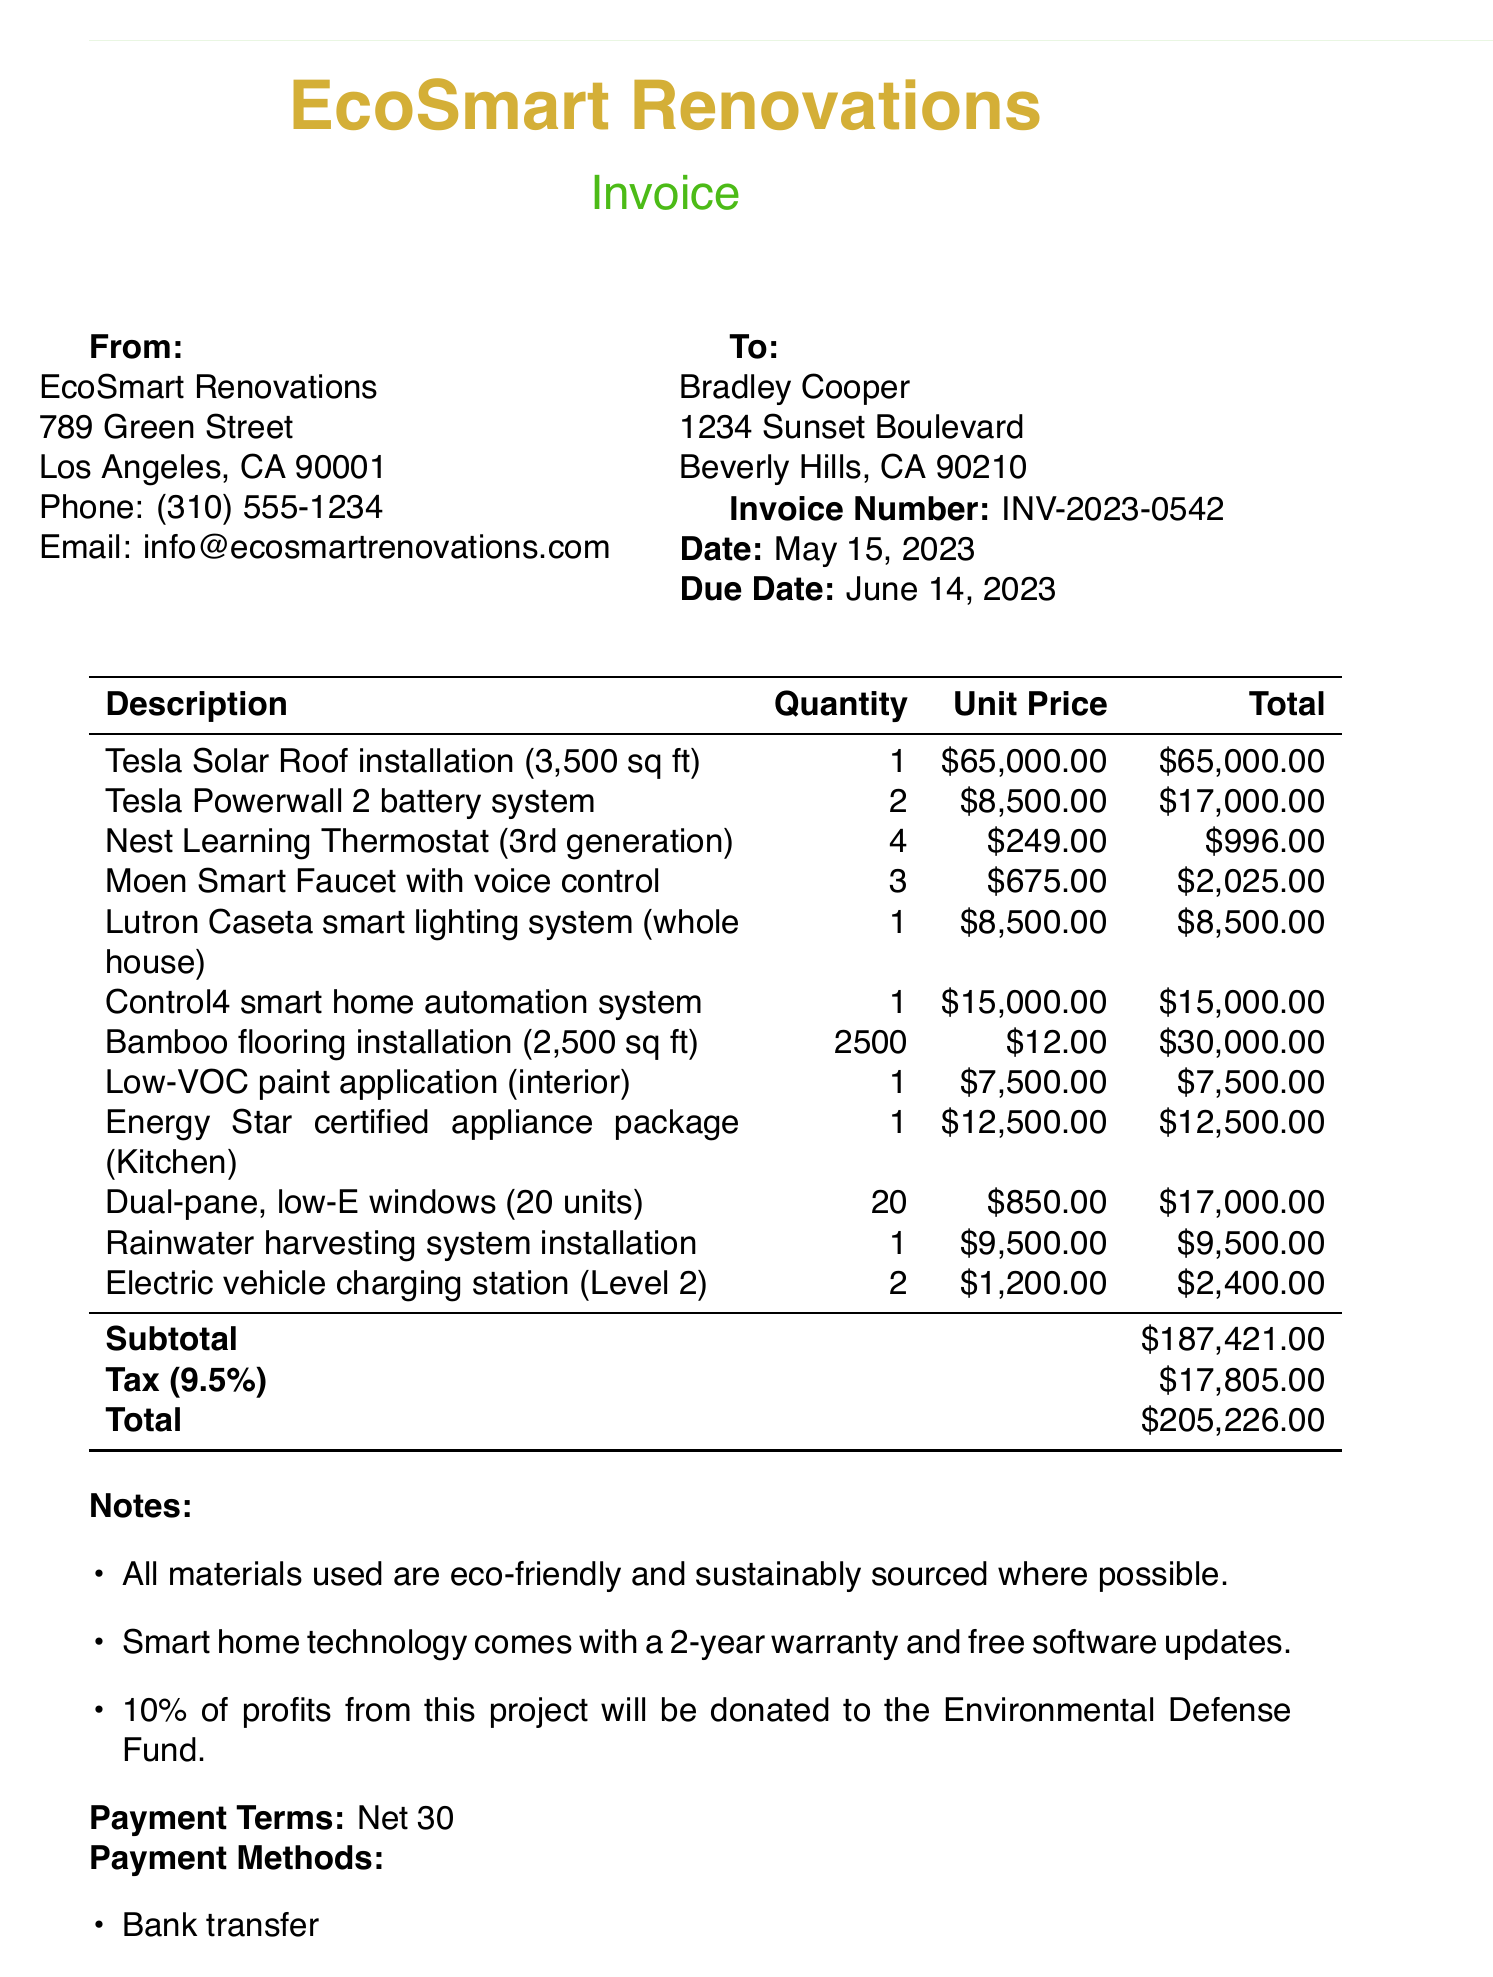What is the invoice number? The invoice number is specified at the beginning of the document and is clearly stated.
Answer: INV-2023-0542 Who is the contractor for this project? The contractor's name is mentioned in the document as the company responsible for the renovation.
Answer: EcoSmart Renovations What is the subtotal amount? The subtotal is calculated from the line items listed and is specifically noted in the document.
Answer: $187,421.00 When is the payment due? The payment due date is indicated next to the invoice date in the document.
Answer: June 14, 2023 How many Nest Learning Thermostats were installed? The quantity of the Nest Learning Thermostats is detailed in the line items section of the document.
Answer: 4 What is the tax rate applied? The tax rate is specified in the document and is a key detail for the total calculation.
Answer: 9.5% What is the total amount due? The total amount due is summarized at the bottom of the invoice and reflects all charges.
Answer: $205,226.00 What sustainable feature is included in the flooring? The document notes the type of materials used in the flooring installation.
Answer: Bamboo What payment methods are accepted? The document lists the various methods of payment provided for the invoice.
Answer: Bank transfer, Credit card, PayPal What percentage of profits will be donated? The document includes a note on the philanthropic aspect of this project, indicating the amount to be donated.
Answer: 10% 